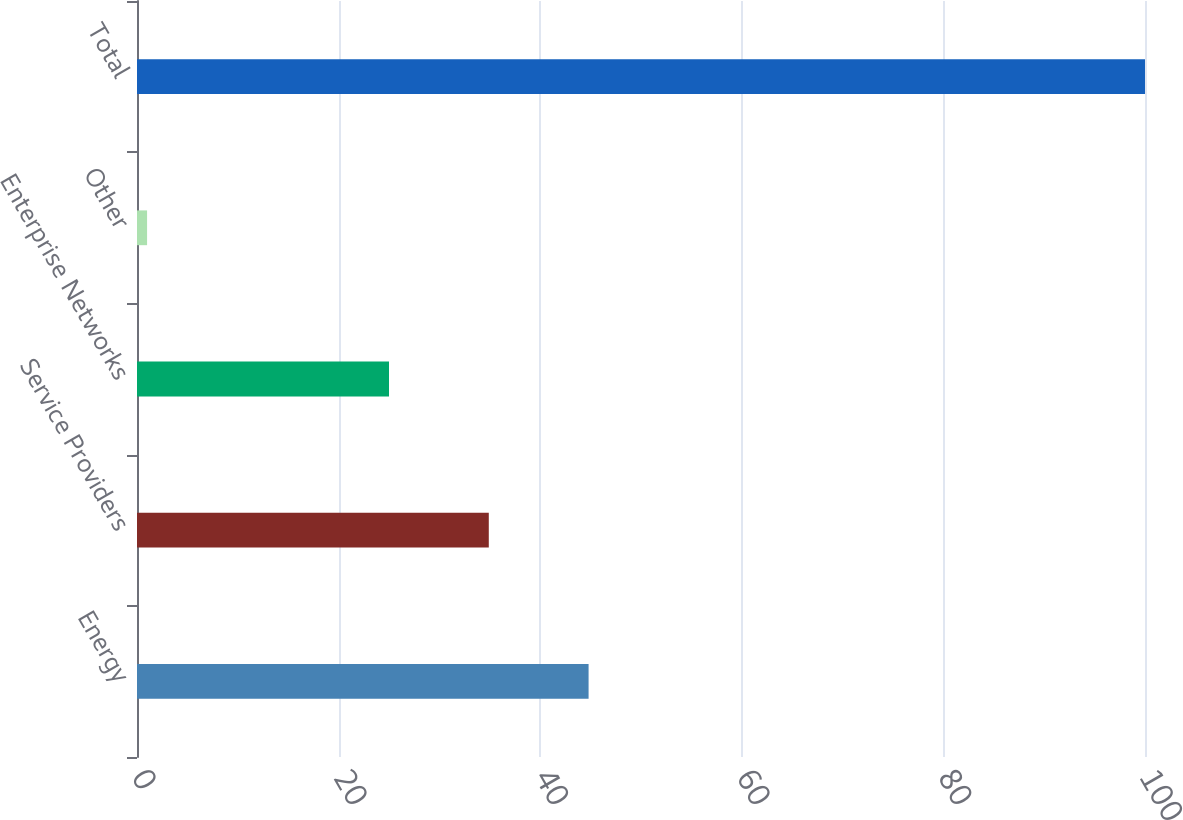Convert chart to OTSL. <chart><loc_0><loc_0><loc_500><loc_500><bar_chart><fcel>Energy<fcel>Service Providers<fcel>Enterprise Networks<fcel>Other<fcel>Total<nl><fcel>44.8<fcel>34.9<fcel>25<fcel>1<fcel>100<nl></chart> 